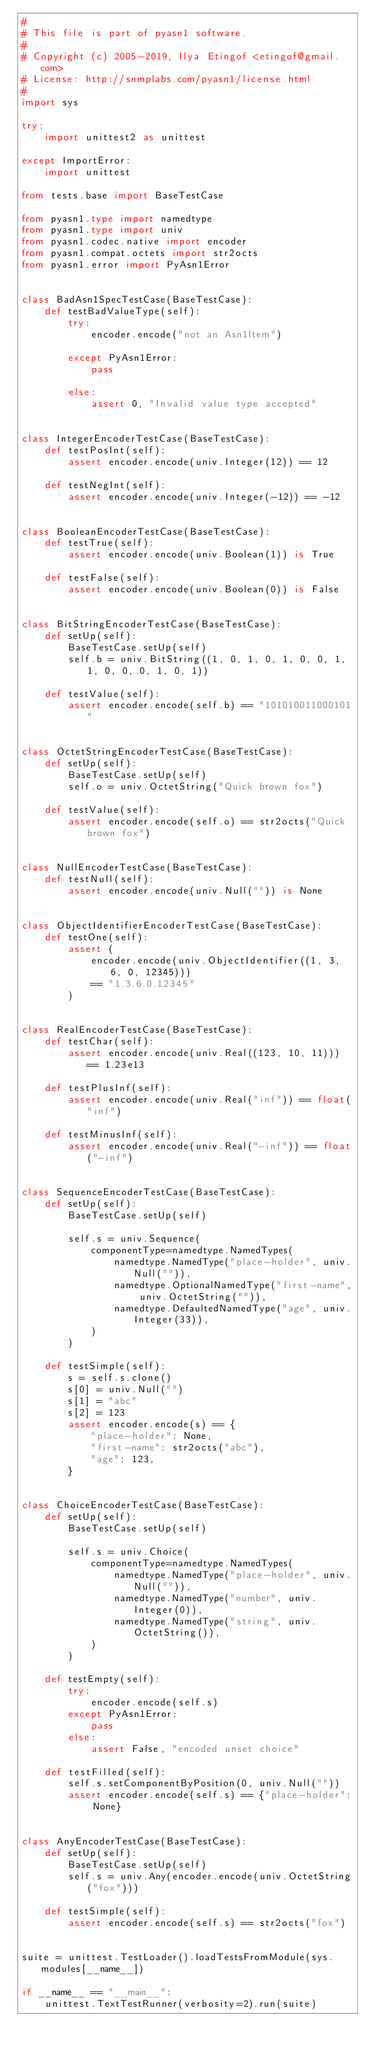<code> <loc_0><loc_0><loc_500><loc_500><_Python_>#
# This file is part of pyasn1 software.
#
# Copyright (c) 2005-2019, Ilya Etingof <etingof@gmail.com>
# License: http://snmplabs.com/pyasn1/license.html
#
import sys

try:
    import unittest2 as unittest

except ImportError:
    import unittest

from tests.base import BaseTestCase

from pyasn1.type import namedtype
from pyasn1.type import univ
from pyasn1.codec.native import encoder
from pyasn1.compat.octets import str2octs
from pyasn1.error import PyAsn1Error


class BadAsn1SpecTestCase(BaseTestCase):
    def testBadValueType(self):
        try:
            encoder.encode("not an Asn1Item")

        except PyAsn1Error:
            pass

        else:
            assert 0, "Invalid value type accepted"


class IntegerEncoderTestCase(BaseTestCase):
    def testPosInt(self):
        assert encoder.encode(univ.Integer(12)) == 12

    def testNegInt(self):
        assert encoder.encode(univ.Integer(-12)) == -12


class BooleanEncoderTestCase(BaseTestCase):
    def testTrue(self):
        assert encoder.encode(univ.Boolean(1)) is True

    def testFalse(self):
        assert encoder.encode(univ.Boolean(0)) is False


class BitStringEncoderTestCase(BaseTestCase):
    def setUp(self):
        BaseTestCase.setUp(self)
        self.b = univ.BitString((1, 0, 1, 0, 1, 0, 0, 1, 1, 0, 0, 0, 1, 0, 1))

    def testValue(self):
        assert encoder.encode(self.b) == "101010011000101"


class OctetStringEncoderTestCase(BaseTestCase):
    def setUp(self):
        BaseTestCase.setUp(self)
        self.o = univ.OctetString("Quick brown fox")

    def testValue(self):
        assert encoder.encode(self.o) == str2octs("Quick brown fox")


class NullEncoderTestCase(BaseTestCase):
    def testNull(self):
        assert encoder.encode(univ.Null("")) is None


class ObjectIdentifierEncoderTestCase(BaseTestCase):
    def testOne(self):
        assert (
            encoder.encode(univ.ObjectIdentifier((1, 3, 6, 0, 12345)))
            == "1.3.6.0.12345"
        )


class RealEncoderTestCase(BaseTestCase):
    def testChar(self):
        assert encoder.encode(univ.Real((123, 10, 11))) == 1.23e13

    def testPlusInf(self):
        assert encoder.encode(univ.Real("inf")) == float("inf")

    def testMinusInf(self):
        assert encoder.encode(univ.Real("-inf")) == float("-inf")


class SequenceEncoderTestCase(BaseTestCase):
    def setUp(self):
        BaseTestCase.setUp(self)

        self.s = univ.Sequence(
            componentType=namedtype.NamedTypes(
                namedtype.NamedType("place-holder", univ.Null("")),
                namedtype.OptionalNamedType("first-name", univ.OctetString("")),
                namedtype.DefaultedNamedType("age", univ.Integer(33)),
            )
        )

    def testSimple(self):
        s = self.s.clone()
        s[0] = univ.Null("")
        s[1] = "abc"
        s[2] = 123
        assert encoder.encode(s) == {
            "place-holder": None,
            "first-name": str2octs("abc"),
            "age": 123,
        }


class ChoiceEncoderTestCase(BaseTestCase):
    def setUp(self):
        BaseTestCase.setUp(self)

        self.s = univ.Choice(
            componentType=namedtype.NamedTypes(
                namedtype.NamedType("place-holder", univ.Null("")),
                namedtype.NamedType("number", univ.Integer(0)),
                namedtype.NamedType("string", univ.OctetString()),
            )
        )

    def testEmpty(self):
        try:
            encoder.encode(self.s)
        except PyAsn1Error:
            pass
        else:
            assert False, "encoded unset choice"

    def testFilled(self):
        self.s.setComponentByPosition(0, univ.Null(""))
        assert encoder.encode(self.s) == {"place-holder": None}


class AnyEncoderTestCase(BaseTestCase):
    def setUp(self):
        BaseTestCase.setUp(self)
        self.s = univ.Any(encoder.encode(univ.OctetString("fox")))

    def testSimple(self):
        assert encoder.encode(self.s) == str2octs("fox")


suite = unittest.TestLoader().loadTestsFromModule(sys.modules[__name__])

if __name__ == "__main__":
    unittest.TextTestRunner(verbosity=2).run(suite)
</code> 